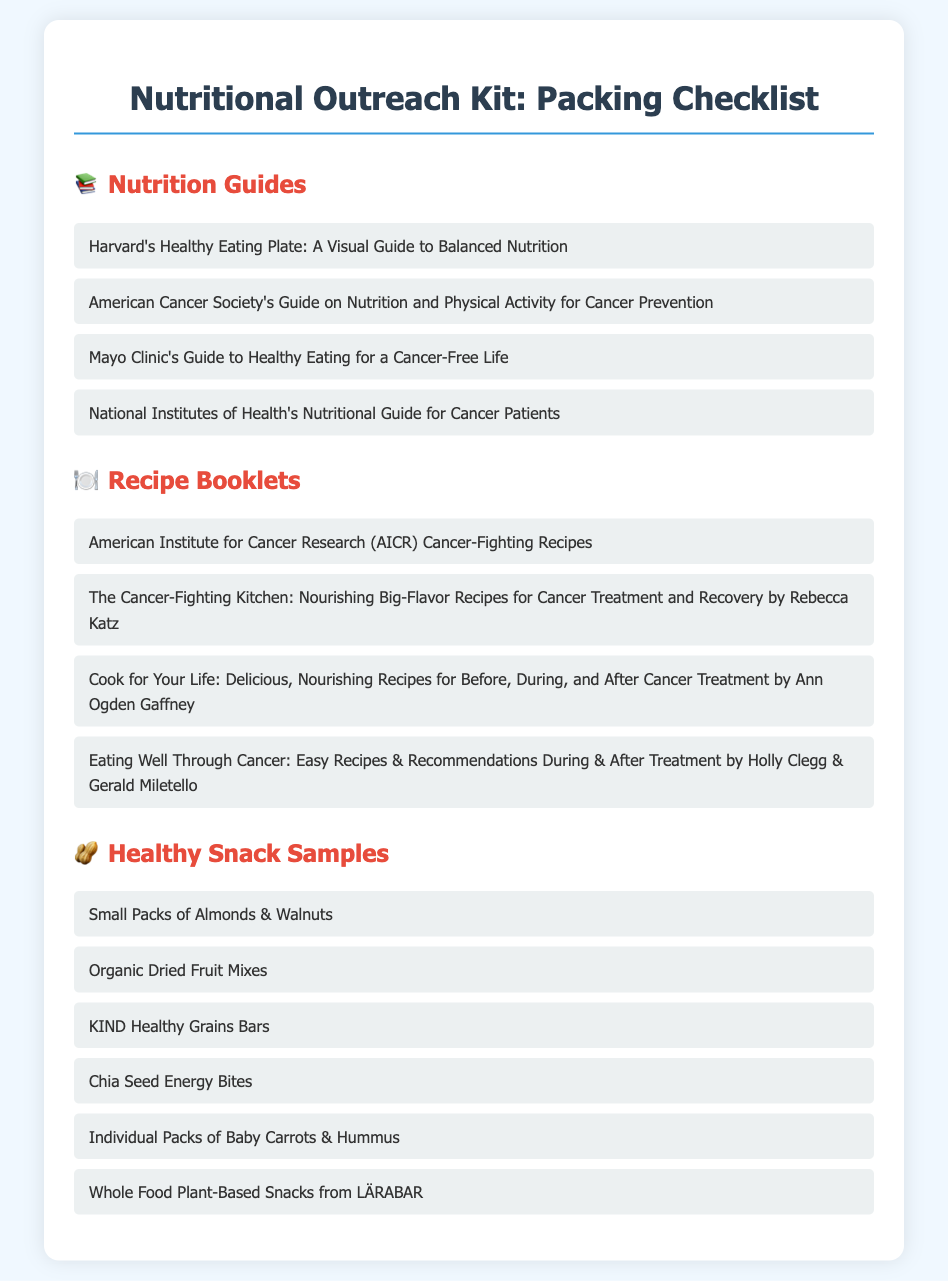What are the first listed nutrition guides? The first guide listed is Harvard's Healthy Eating Plate, which is part of the nutrition guides section.
Answer: Harvard's Healthy Eating Plate How many recipe booklets are mentioned? The document contains a total of four recipe booklets listed in the recipe section.
Answer: 4 Which organization is associated with cancer-fighting recipes? The document mentions the American Institute for Cancer Research (AICR) related to cancer-fighting recipes.
Answer: American Institute for Cancer Research What type of healthy snacks are mentioned that include a vegetable? The individual packs of baby carrots & hummus are mentioned as a type of healthy snack.
Answer: Baby Carrots & Hummus What can be found in the section under healthy snack samples? The healthy snack samples section lists different nutritious snack options for outreach, including energy bites and bars.
Answer: Small Packs of Almonds & Walnuts, Organic Dried Fruit Mixes, KIND Healthy Grains Bars, Chia Seed Energy Bites, Individual Packs of Baby Carrots & Hummus, Whole Food Plant-Based Snacks from LÄRABAR Which document focuses on nutrition and physical activity for cancer prevention? The document includes the American Cancer Society's Guide on Nutrition and Physical Activity for Cancer Prevention explicitly listed among the nutrition guides.
Answer: American Cancer Society's Guide on Nutrition and Physical Activity for Cancer Prevention What is the title of the recipe booklet authored by Rebecca Katz? The title The Cancer-Fighting Kitchen: Nourishing Big-Flavor Recipes for Cancer Treatment and Recovery is noted in the recipe booklets section.
Answer: The Cancer-Fighting Kitchen How many healthy snack samples are included in the list? The document lists six different healthy snack samples for the outreach kit.
Answer: 6 